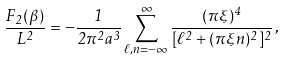<formula> <loc_0><loc_0><loc_500><loc_500>\frac { F _ { 2 } ( \beta ) } { L ^ { 2 } } = - \frac { 1 } { 2 \pi ^ { 2 } a ^ { 3 } } \sum _ { \ell , n = - \infty } ^ { \infty } \frac { ( \pi \xi ) ^ { 4 } } { [ \ell ^ { 2 } + ( \pi \xi n ) ^ { 2 } ] ^ { 2 } } \, ,</formula> 